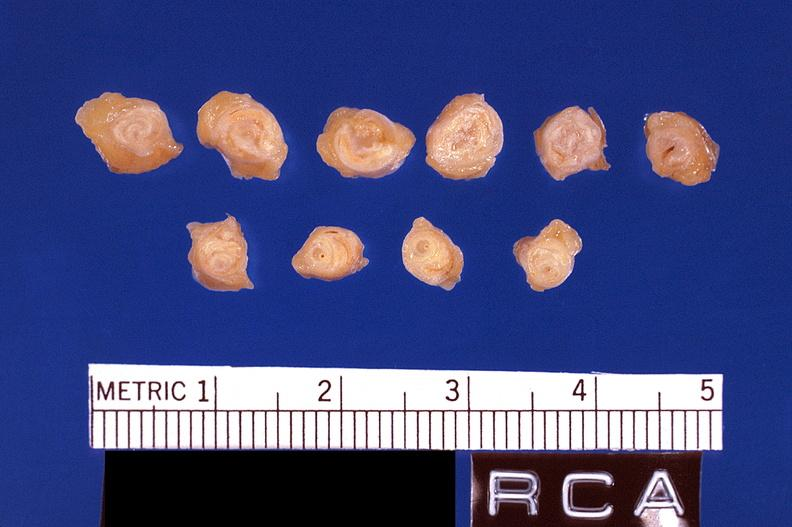what is present?
Answer the question using a single word or phrase. Vasculature 